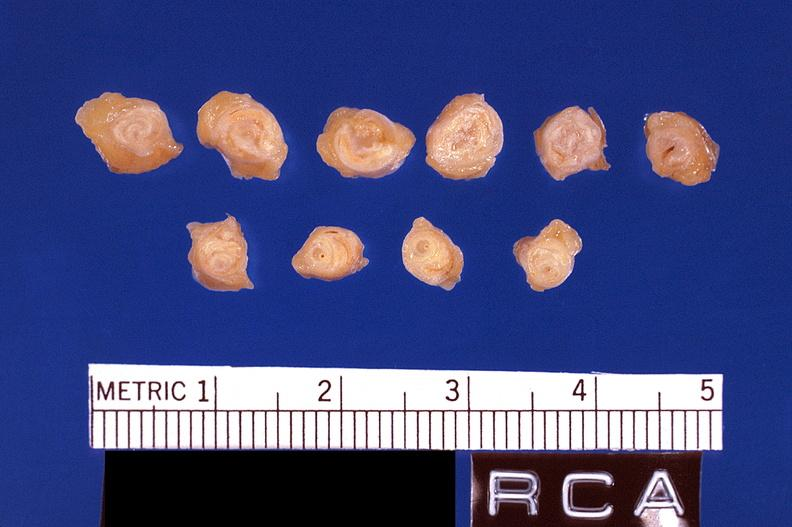what is present?
Answer the question using a single word or phrase. Vasculature 